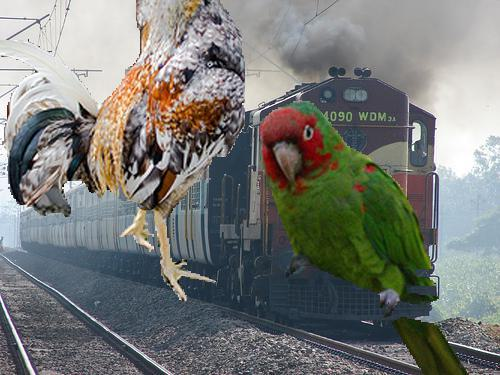How does the juxtaposition of the animals and the train affect the viewer's perception of the scene? The juxtaposition introduces a surreal or comic effect, disrupting the typical industrial scene with elements of natural and more whimsical life. This contrast not only catches the viewer's attention but also encourages a reflection on the relationship between human technology and the natural world, perhaps highlighting the unexpected intrusions of nature into human-constructed environments. 